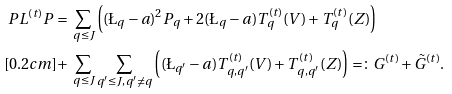<formula> <loc_0><loc_0><loc_500><loc_500>P L ^ { ( t ) } P = & \ \sum _ { q \leq J } \left ( ( \L _ { q } - a ) ^ { 2 } P _ { q } + 2 ( \L _ { q } - a ) T _ { q } ^ { ( t ) } ( V ) + T _ { q } ^ { ( t ) } ( Z ) \right ) \\ [ 0 . 2 c m ] + & \ \sum _ { q \leq J } \sum _ { q ^ { \prime } \leq J , q ^ { \prime } \not = q } \left ( ( \L _ { q ^ { \prime } } - a ) T _ { q , q ^ { \prime } } ^ { ( t ) } ( V ) + T _ { q , q ^ { \prime } } ^ { ( t ) } ( Z ) \right ) = \colon G ^ { ( t ) } + \tilde { G } ^ { ( t ) } .</formula> 